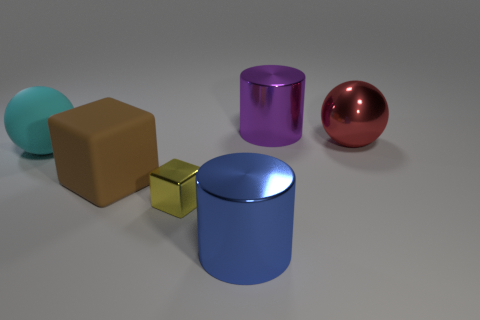Subtract all brown cubes. How many cubes are left? 1 Add 3 large metal balls. How many objects exist? 9 Subtract all cubes. How many objects are left? 4 Subtract 2 cubes. How many cubes are left? 0 Subtract all blue cylinders. Subtract all blue spheres. How many cylinders are left? 1 Subtract all tiny brown rubber things. Subtract all big blue objects. How many objects are left? 5 Add 6 blue objects. How many blue objects are left? 7 Add 6 yellow objects. How many yellow objects exist? 7 Subtract 0 cyan cylinders. How many objects are left? 6 